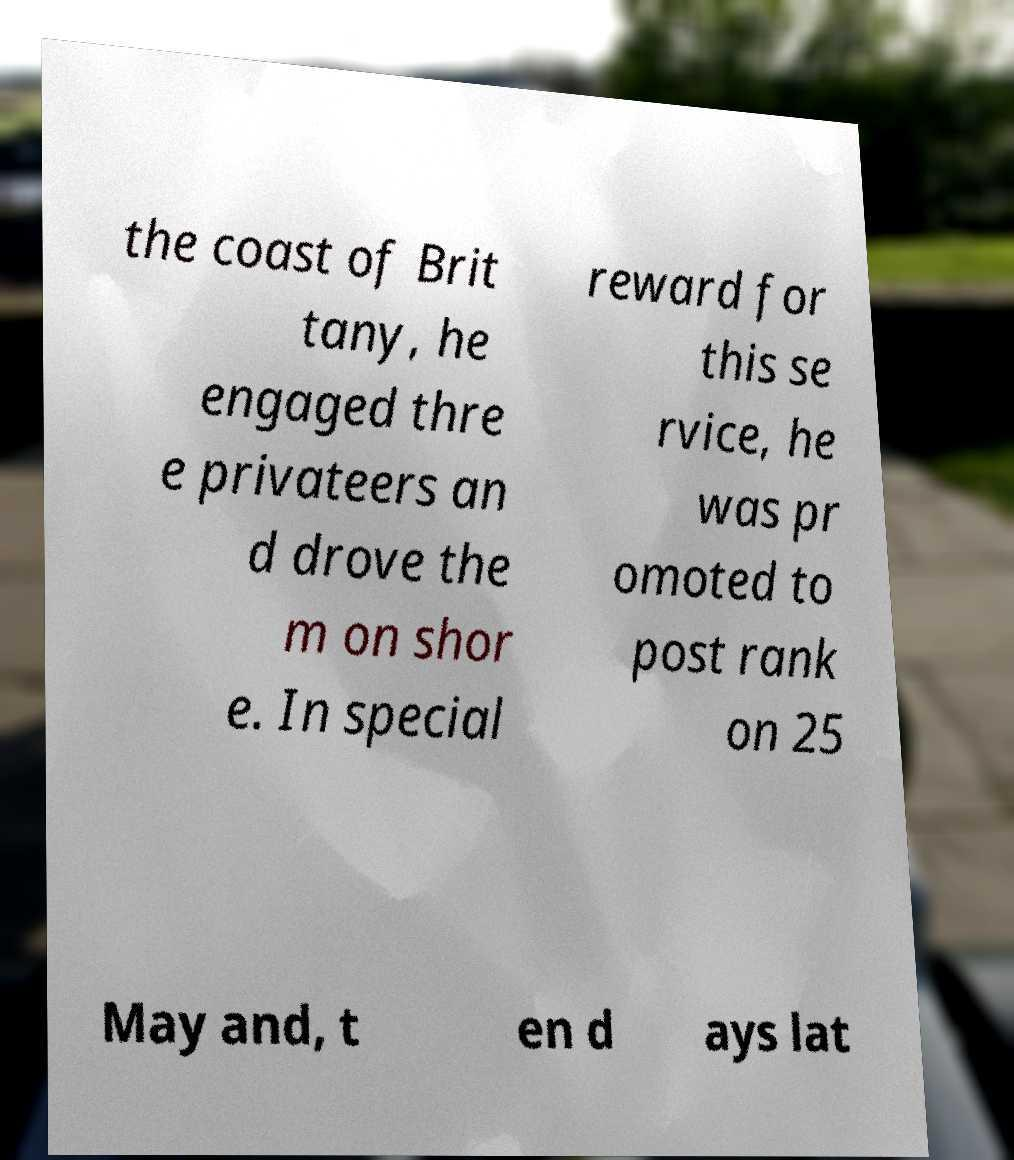Could you assist in decoding the text presented in this image and type it out clearly? the coast of Brit tany, he engaged thre e privateers an d drove the m on shor e. In special reward for this se rvice, he was pr omoted to post rank on 25 May and, t en d ays lat 